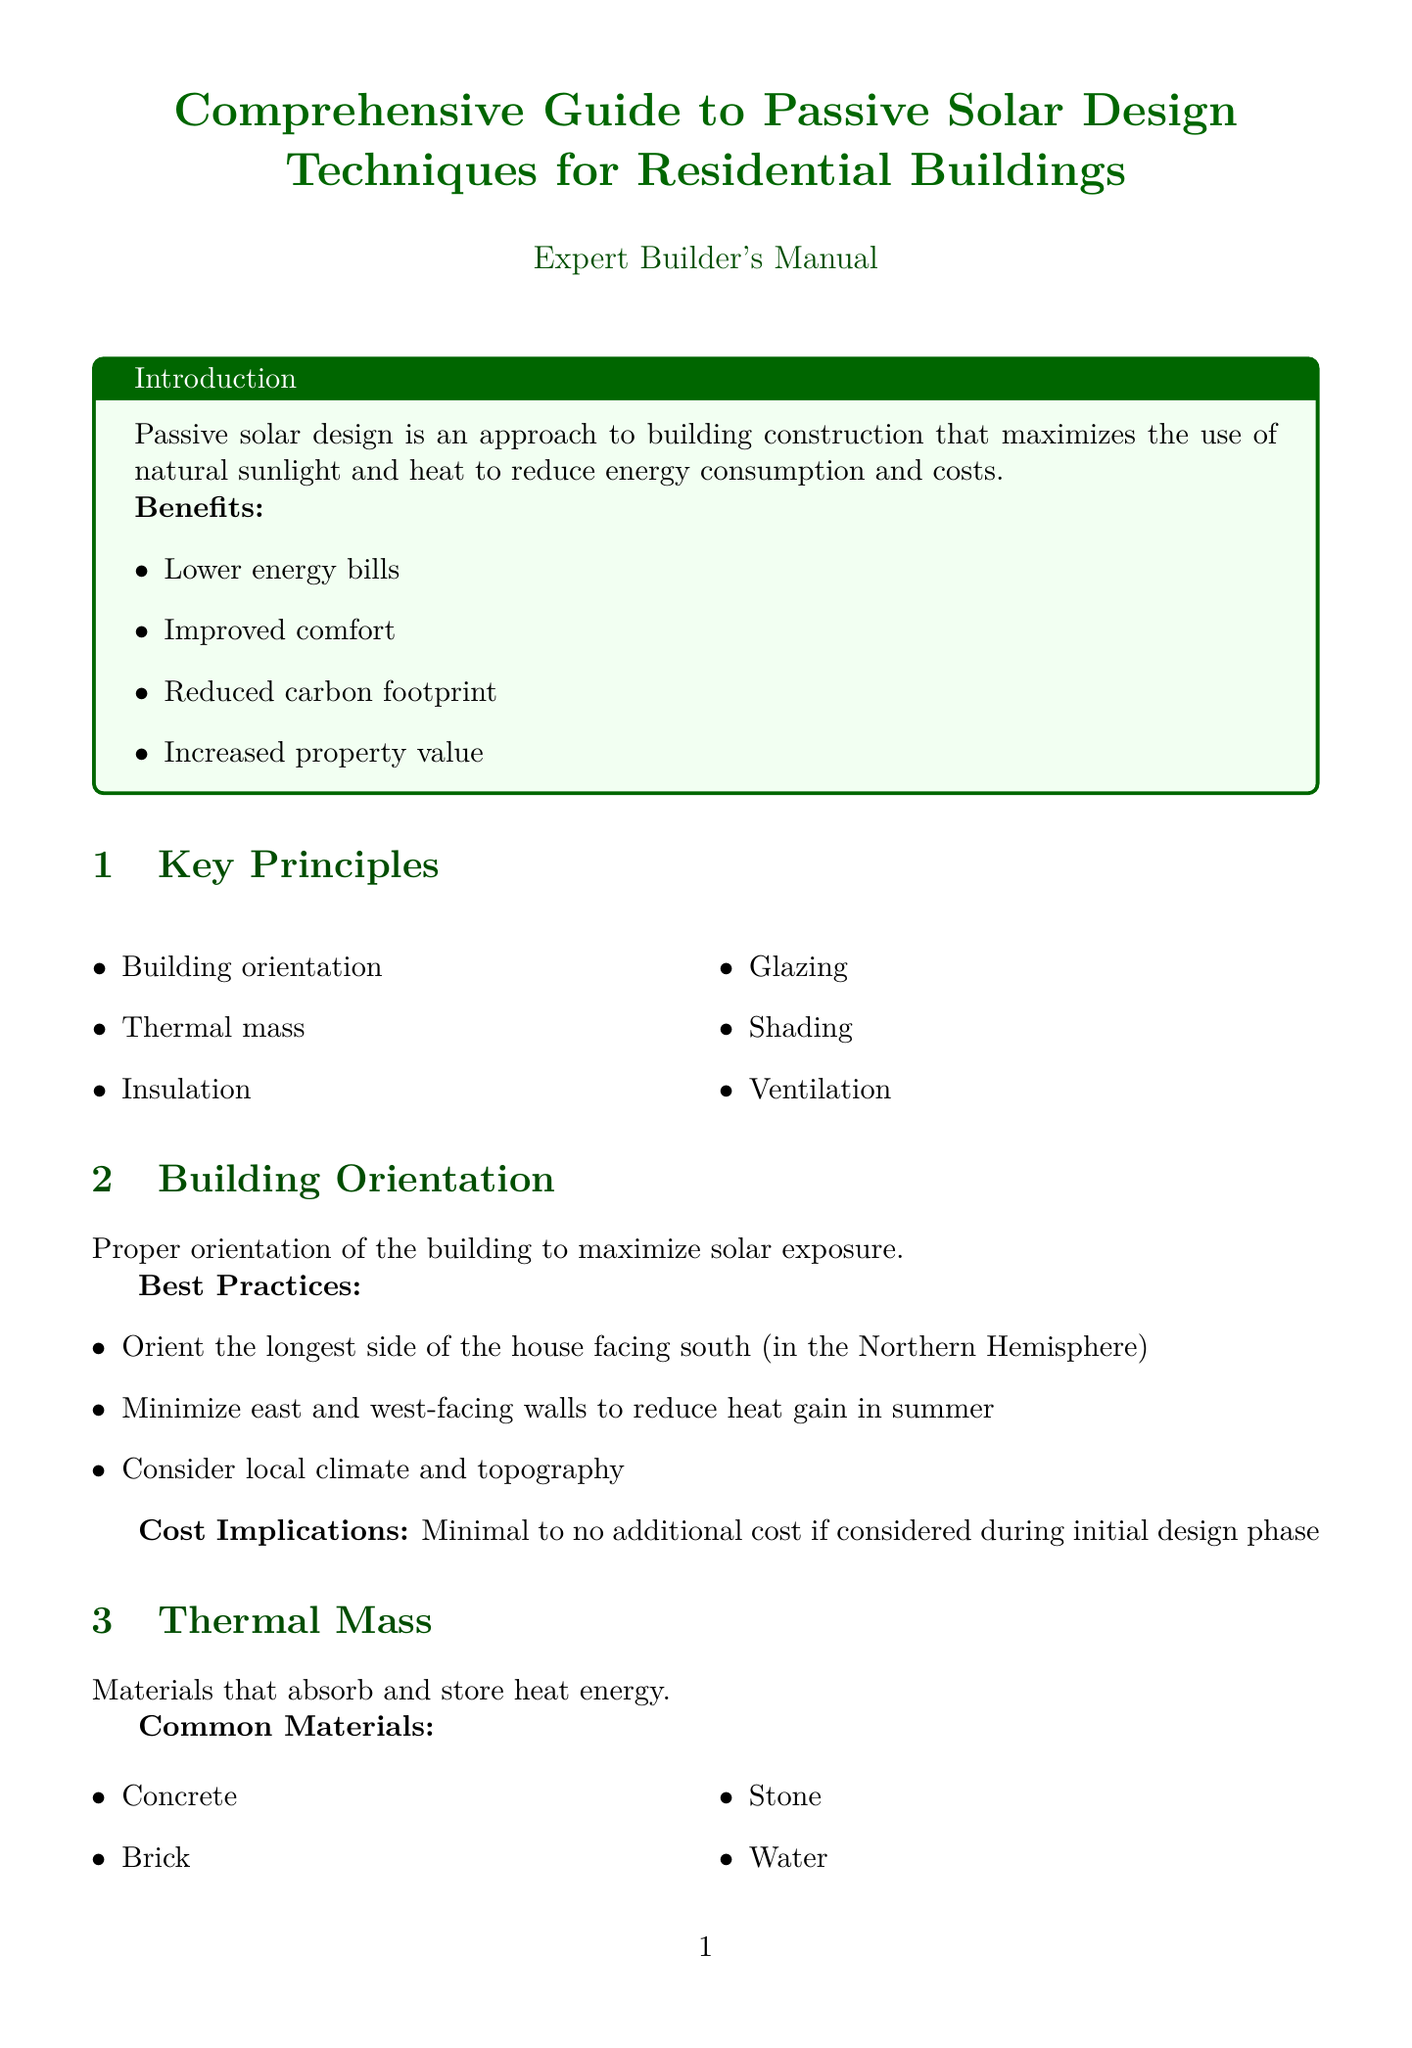what is passive solar design? Passive solar design is defined in the introduction as an approach to building construction that maximizes the use of natural sunlight and heat to reduce energy consumption and costs.
Answer: An approach to building construction that maximizes natural sunlight and heat what are the benefits of passive solar design? The benefits are listed in the introduction of the document.
Answer: Lower energy bills, Improved comfort, Reduced carbon footprint, Increased property value what is the cost estimate for thermal mass materials? The document provides a cost estimate for thermal mass materials in the relevant section.
Answer: $5 - $15 per square foot how should buildings be oriented for passive solar design? Best practices for building orientation are outlined, indicating how to face the longest side of the building.
Answer: Orient the longest side of the house facing south what is the payback period for passive solar design investment? The cost analysis section mentions the payback period for investments in passive solar design.
Answer: 7-10 years which materials are recommended for insulation? The document specifically lists recommended types of insulation materials.
Answer: Fiberglass batts, Spray foam, Cellulose, Rigid foam board what percentage of reduction in cooling costs was achieved by Breezeway Residence? The energy savings for the Breezeway Residence are provided in the case studies section.
Answer: 50% reduction in cooling costs how can unwanted solar heat gain be reduced? The shading section describes methods to mitigate solar heat gain.
Answer: Roof overhangs, Awnings, Exterior shutters, Deciduous trees which window features are suggested for optimal solar gain? The considerations for glazing detail specific features for windows.
Answer: Window size and placement, Glass type, Frame material 